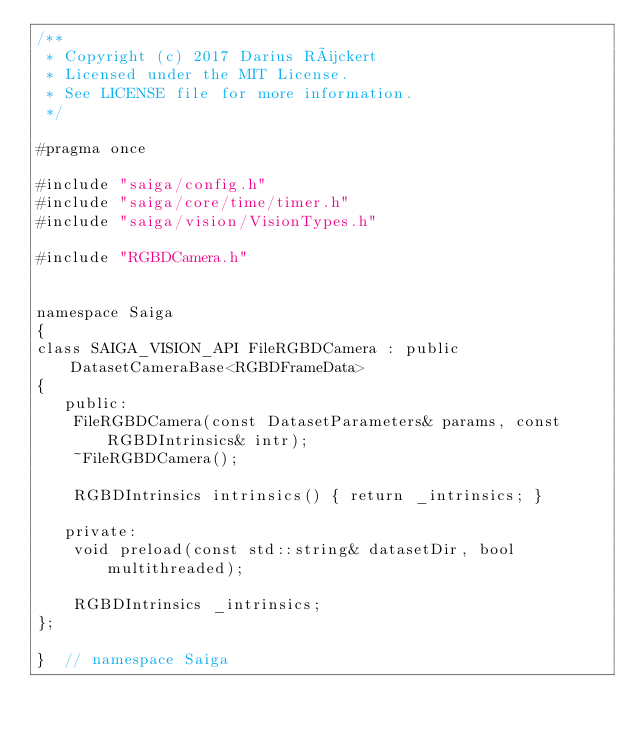Convert code to text. <code><loc_0><loc_0><loc_500><loc_500><_C_>/**
 * Copyright (c) 2017 Darius Rückert
 * Licensed under the MIT License.
 * See LICENSE file for more information.
 */

#pragma once

#include "saiga/config.h"
#include "saiga/core/time/timer.h"
#include "saiga/vision/VisionTypes.h"

#include "RGBDCamera.h"


namespace Saiga
{
class SAIGA_VISION_API FileRGBDCamera : public DatasetCameraBase<RGBDFrameData>
{
   public:
    FileRGBDCamera(const DatasetParameters& params, const RGBDIntrinsics& intr);
    ~FileRGBDCamera();

    RGBDIntrinsics intrinsics() { return _intrinsics; }

   private:
    void preload(const std::string& datasetDir, bool multithreaded);

    RGBDIntrinsics _intrinsics;
};

}  // namespace Saiga
</code> 